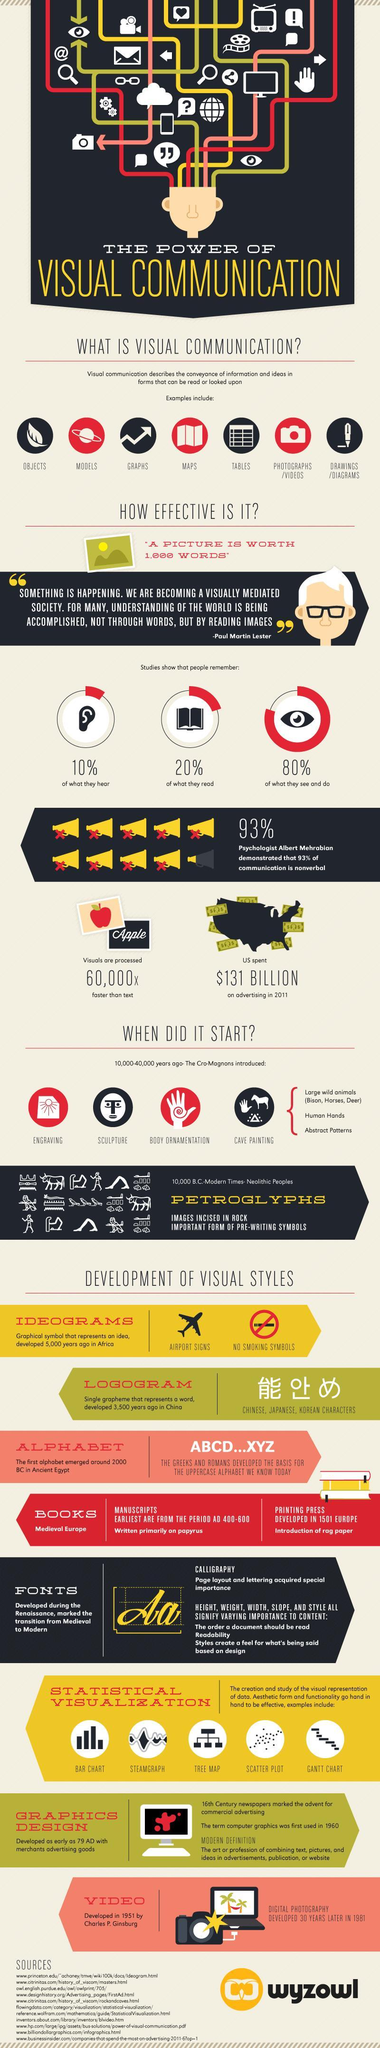What did Cro-Magnons introduce 10,000-40,000 years ago?
Answer the question with a short phrase. Engraving,sculpture,body ornamentation,cave painting What do people remember the most according to studies? what they see and do where was ideograms developed? Africa How many years did it take to develop digital photography from video? 30 years What is an important form of pre-writing symbols? Petroglyphs What do people remember the second most according to studies? what they read 